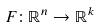<formula> <loc_0><loc_0><loc_500><loc_500>F \colon \mathbb { R } ^ { n } \rightarrow \mathbb { R } ^ { k }</formula> 